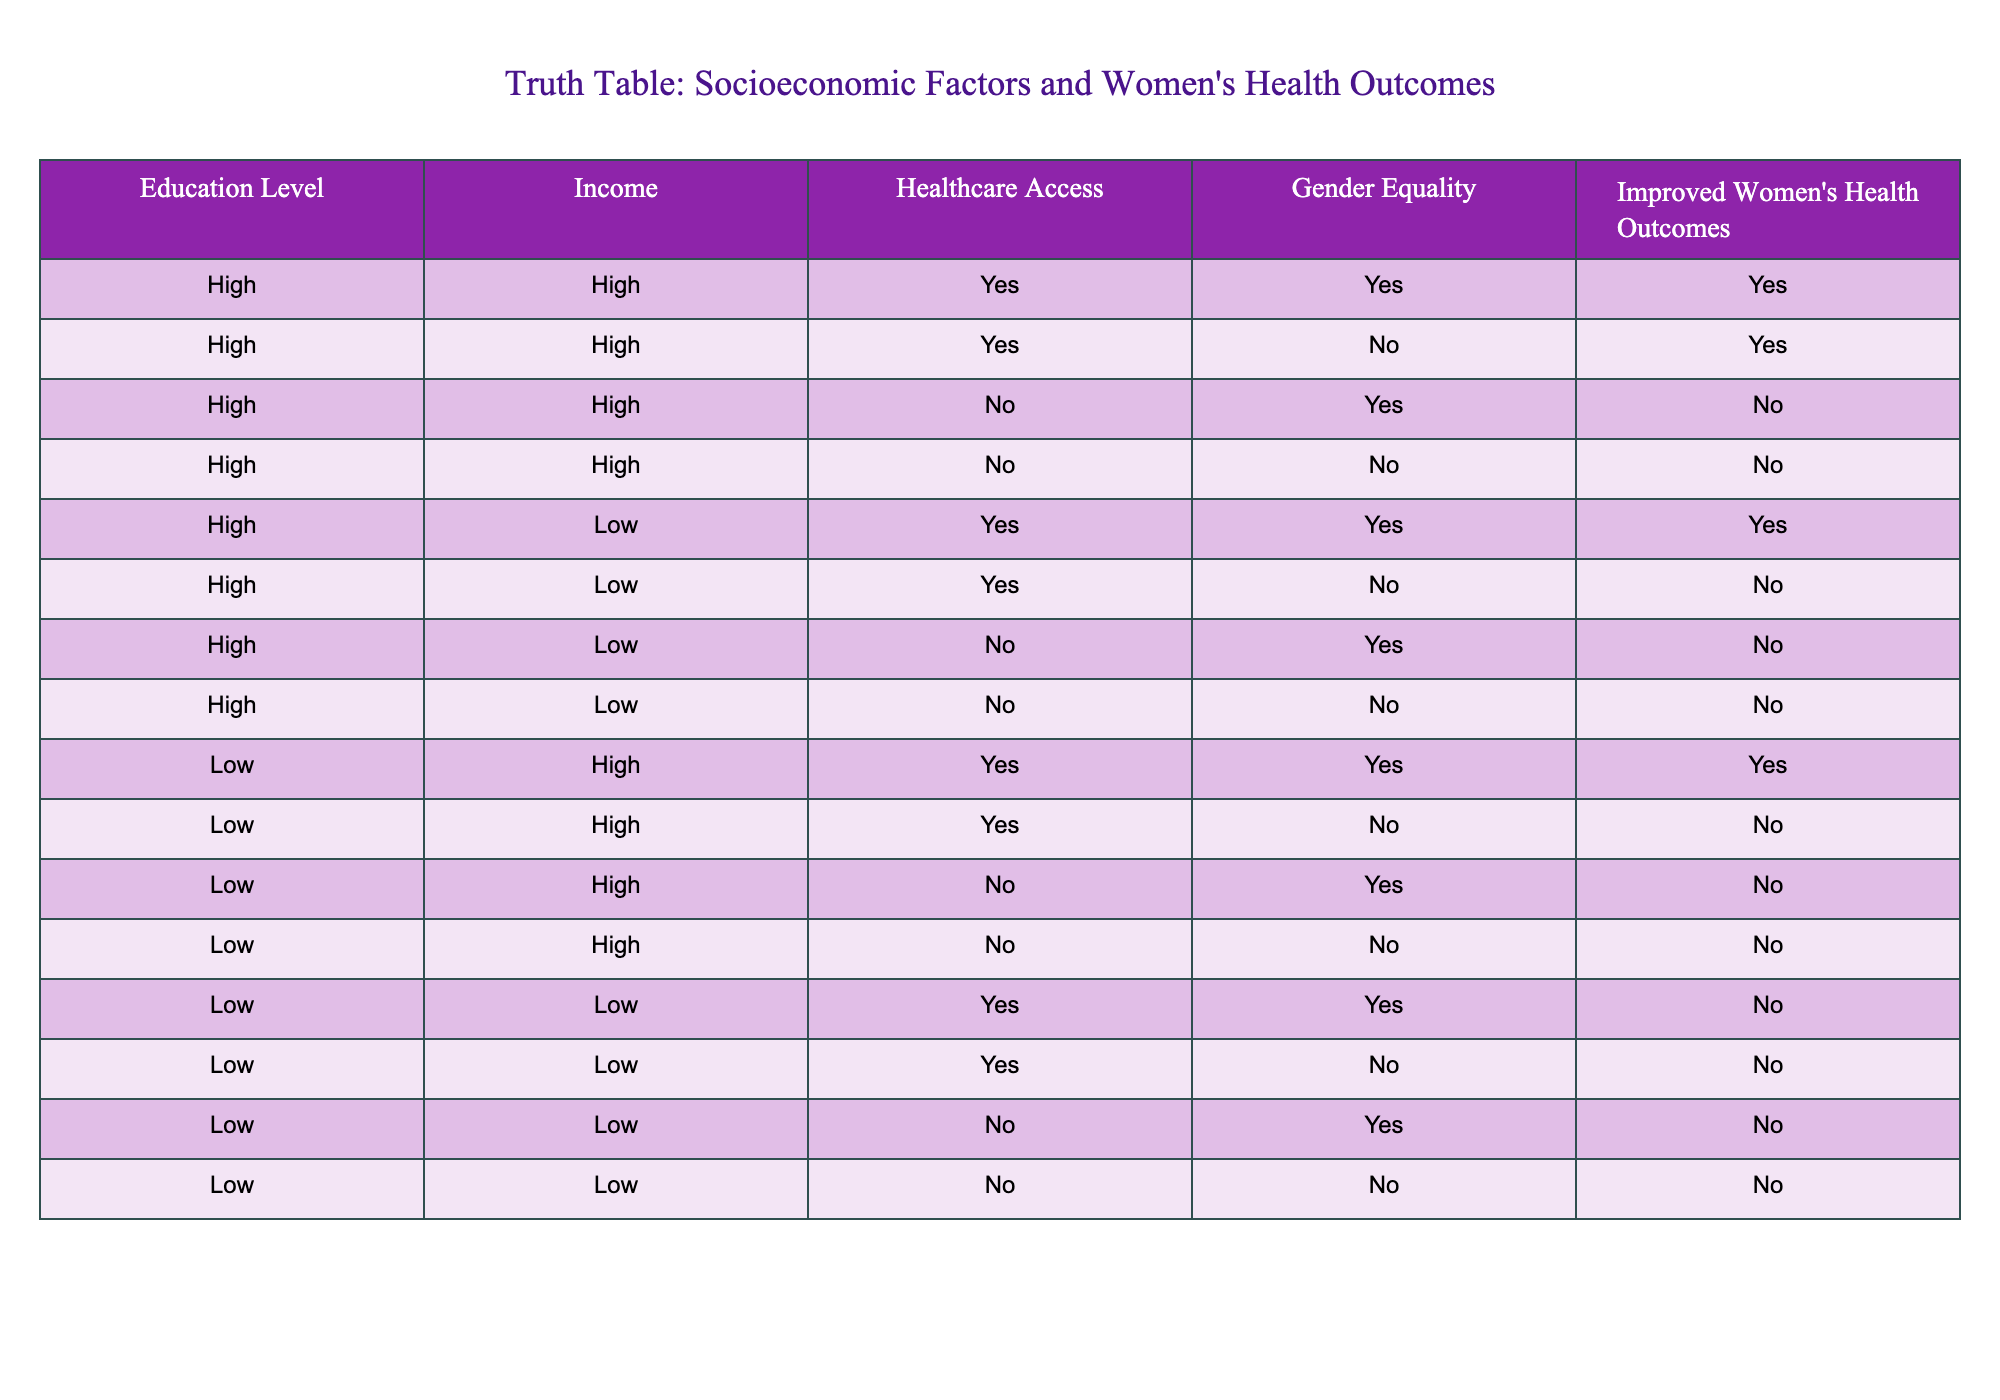What is the relationship between high income and improved women's health outcomes? From the table, we can see that when the income is high, improved women's health outcomes are observed in 4 out of 5 cases (4 with Yes and 1 with No). Therefore, there seems to be a positive relationship between high income and improved women's health outcomes.
Answer: Yes How many cases indicate improved women's health outcomes with low income and gender equality? By examining the rows with low income and gender equality = Yes, we see only one case (the row: Low, Low, Yes, Yes, No). Thus, there is a single case indicating improved women's health outcomes with this condition.
Answer: 0 Is there any instance where women have high healthcare access but low income that leads to poor health outcomes? Looking through the table, there is one case where low income coincides with high healthcare access but results in No for improved women's health outcomes (Low, Low, Yes, Yes, No). Therefore, this condition does exist.
Answer: Yes What is the total number of cases with high education and gender equality that lead to improved women's health outcomes? Upon filtering the table for high education and gender equality as Yes, we find three rows that satisfy this condition (High, High, Yes, Yes, Yes and two others). Consequently, the total number is three cases leading to improved health outcomes.
Answer: 3 Under which conditions does women's health outcomes improve, comparing both income levels? Only high education combined with either high income (4 cases) or low income (1 case) results in improved health outcomes. However, low education does not indicate improved outcomes contributing to the discrepancy. Hence, education level significantly impacts health outcomes alongside income.
Answer: High education, high income 